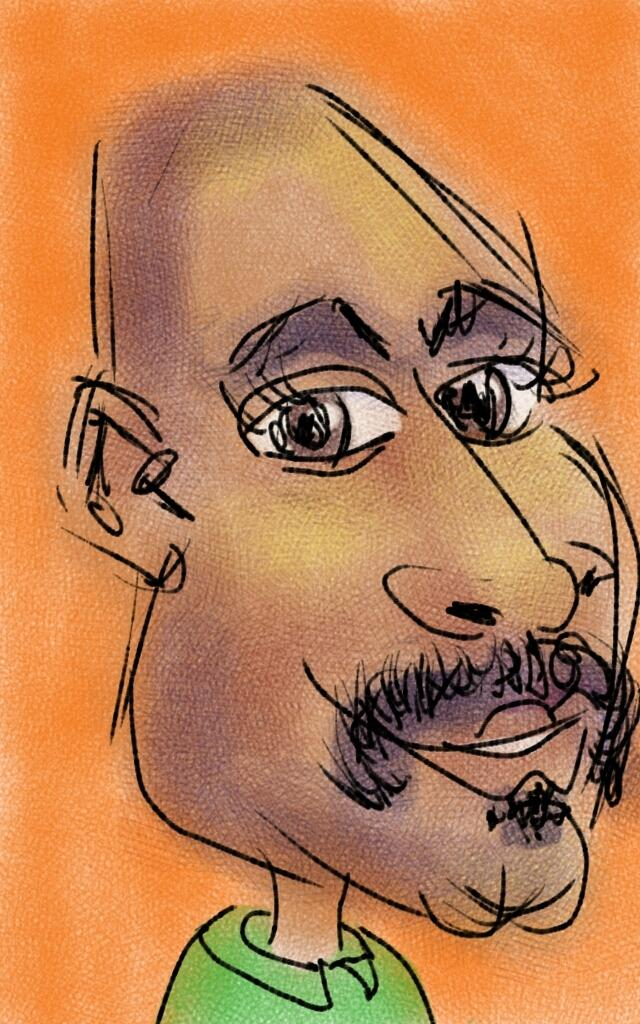What is the main subject of the image? There is an art piece in the image. What is depicted in the art piece? The art piece contains a depiction of a person. What type of mist can be seen surrounding the person in the art piece? There is no mist present in the image; it only contains a depiction of a person. What is the person in the art piece doing with their tail? There is no tail present in the image, as it is a depiction of a person, and humans do not have tails. 